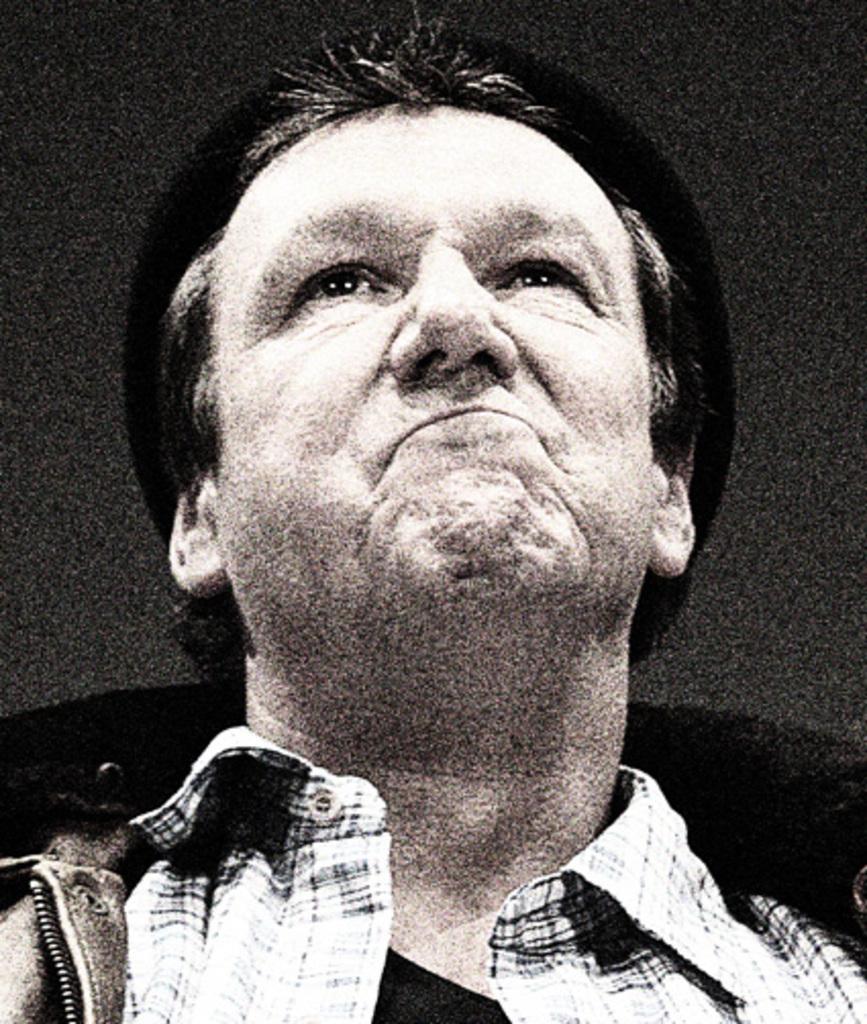Can you describe this image briefly? In this image we can see a man wearing a jacket. 